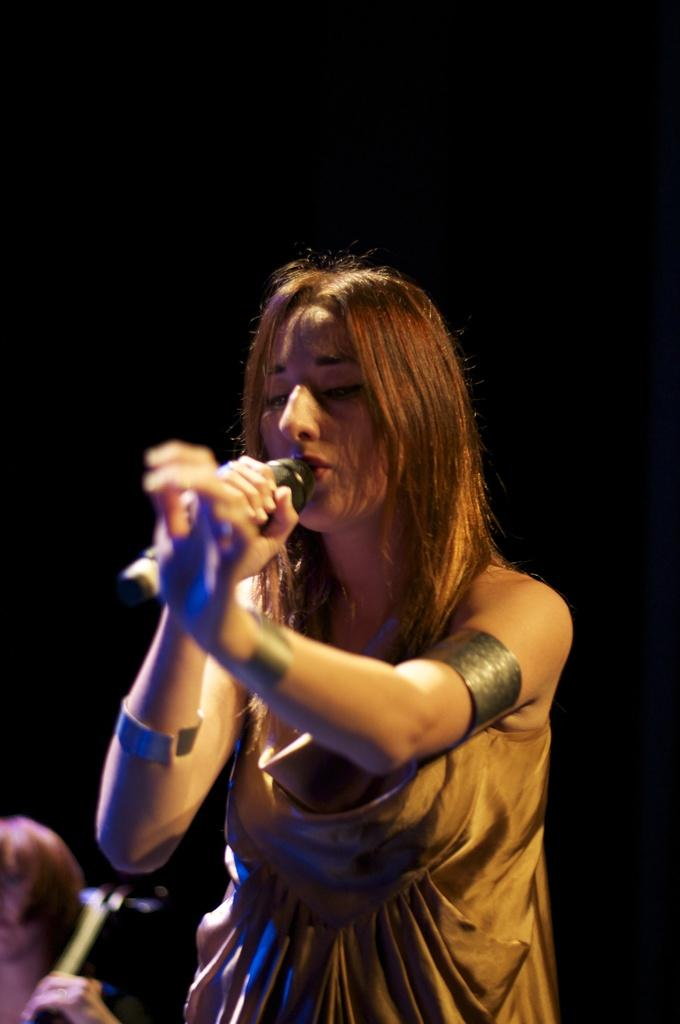What is the woman in the image doing? The woman is standing in the image and holding a microphone. Where is the woman located in the image? The woman is in the middle of the image. Are there any other people visible in the image? Yes, there is another person in the bottom left corner of the image. What type of stamp can be seen on the woman's forehead in the image? There is no stamp visible on the woman's forehead in the image. Can you describe the tiger that is sitting next to the woman in the image? There is no tiger present in the image; the woman is the only person visible. 